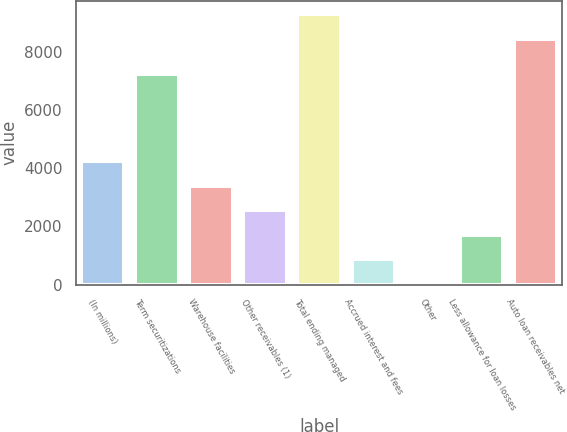Convert chart. <chart><loc_0><loc_0><loc_500><loc_500><bar_chart><fcel>(In millions)<fcel>Term securitizations<fcel>Warehouse facilities<fcel>Other receivables (1)<fcel>Total ending managed<fcel>Accrued interest and fees<fcel>Other<fcel>Less allowance for loan losses<fcel>Auto loan receivables net<nl><fcel>4243<fcel>7226.5<fcel>3399.86<fcel>2556.72<fcel>9278.64<fcel>870.44<fcel>27.3<fcel>1713.58<fcel>8435.5<nl></chart> 